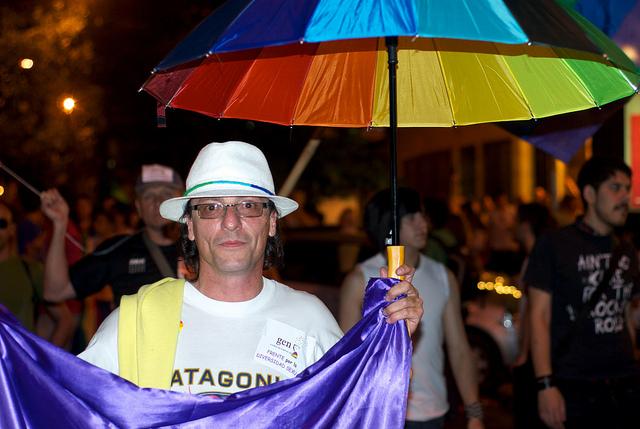Is this outdoors?
Write a very short answer. Yes. What is the person holding?
Short answer required. Umbrella. Is it possible this is a gay pride parade?
Be succinct. Yes. 